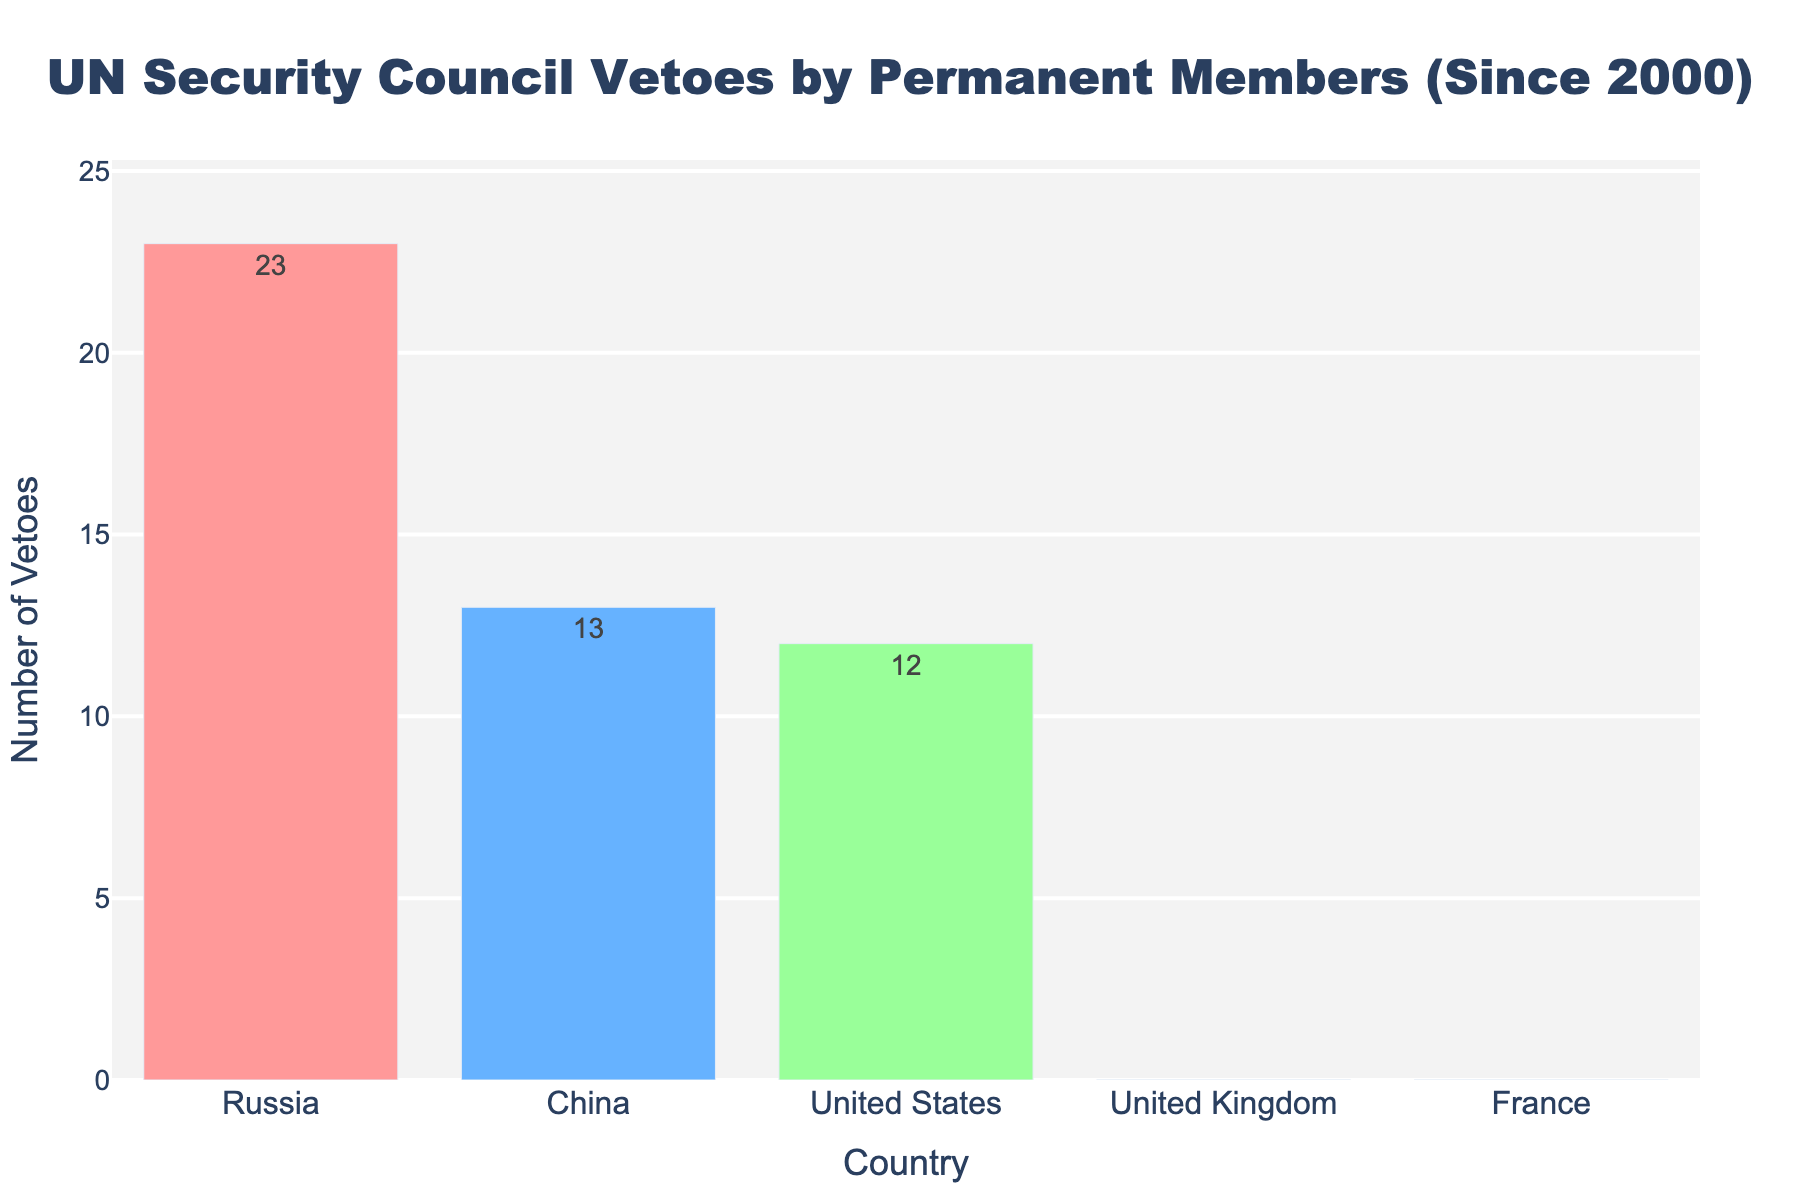What's the total number of vetoes cast by all permanent members since 2000? To find the total number of vetoes, sum the vetoes of all countries: 23 (Russia) + 13 (China) + 12 (United States) + 0 (United Kingdom) + 0 (France) = 48
Answer: 48 Which country has the highest number of vetoes since 2000? The country with the highest number of vetoes is the one with the tallest bar on the plot. Russia has the highest number of vetoes with 23
Answer: Russia How many more vetoes has Russia cast compared to China? The difference in the number of vetoes cast by Russia and China is calculated by subtracting China's vetoes from Russia's vetoes: 23 - 13 = 10
Answer: 10 Are there any countries with no vetoes since 2000? If so, which ones? The countries with no vetoes are represented by bars with zero height. Both the United Kingdom and France have 0 vetoes
Answer: United Kingdom and France What is the combined total of vetoes cast by the United Kingdom and France? Add the number of vetoes cast by the United Kingdom and France: 0 (United Kingdom) + 0 (France) = 0
Answer: 0 What is the average number of vetoes cast by the United States, China, and Russia? The average is calculated by summing the vetoes and dividing by the number of countries: (12 + 13 + 23) / 3 = 48 / 3 = 16
Answer: 16 Which two countries together have fewer vetoes than the United States alone? Add the vetoes of each possible pair and compare with the vetoes of the United States (12). The pairs France & United Kingdom, and France & China have fewer vetoes than the United States: 0 (France) + 0 (UK) = 0 and 0 (France) + 13 (China) = 13. Only France and the UK pair have fewer vetoes than 12.
Answer: France and United Kingdom Which countries are represented by the bar colors light red and light green, respectively? The light red bar represents Russia, and the light green bar represents the United States
Answer: Russia and United States 